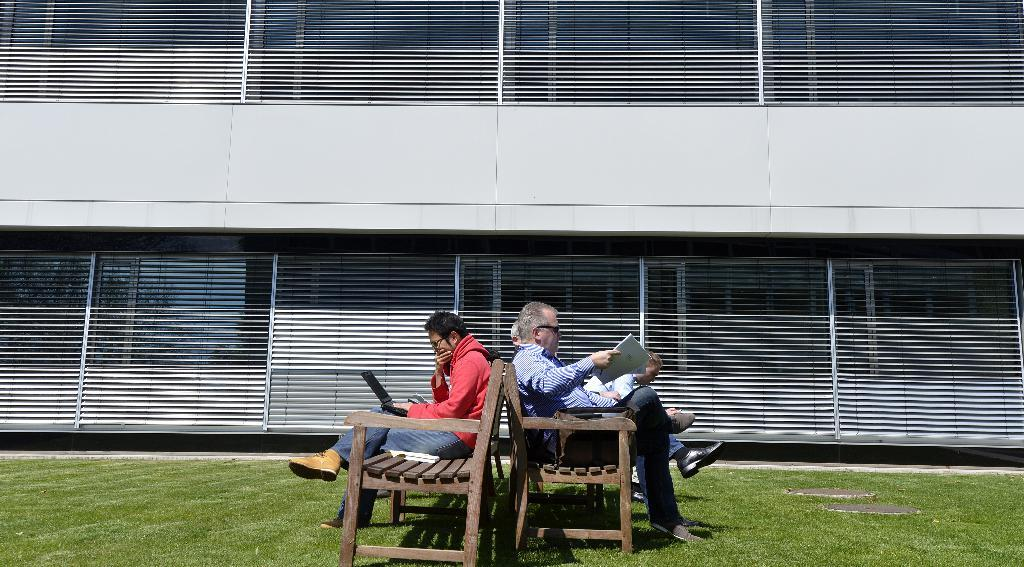What is the man in the image doing? The man is sitting on a bench in the image. What is the old man in the image doing? The old man is sitting on the bench and reading something. Can you describe the clothing of the man in the image? The man is wearing a red coat. What type of structure can be seen in the background of the image? There is no structure visible in the background of the image. What type of education is the old man pursuing in the image? There is no indication in the image that the old man is pursuing any type of education. 